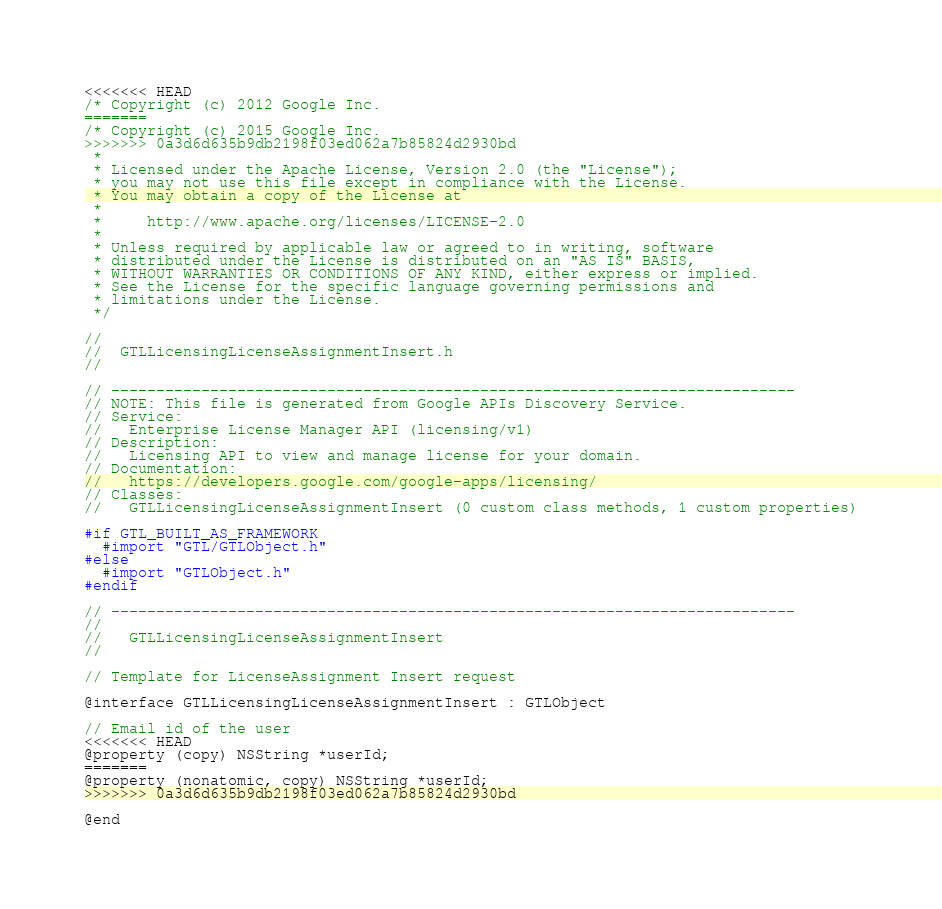<code> <loc_0><loc_0><loc_500><loc_500><_C_><<<<<<< HEAD
/* Copyright (c) 2012 Google Inc.
=======
/* Copyright (c) 2015 Google Inc.
>>>>>>> 0a3d6d635b9db2198f03ed062a7b85824d2930bd
 *
 * Licensed under the Apache License, Version 2.0 (the "License");
 * you may not use this file except in compliance with the License.
 * You may obtain a copy of the License at
 *
 *     http://www.apache.org/licenses/LICENSE-2.0
 *
 * Unless required by applicable law or agreed to in writing, software
 * distributed under the License is distributed on an "AS IS" BASIS,
 * WITHOUT WARRANTIES OR CONDITIONS OF ANY KIND, either express or implied.
 * See the License for the specific language governing permissions and
 * limitations under the License.
 */

//
//  GTLLicensingLicenseAssignmentInsert.h
//

// ----------------------------------------------------------------------------
// NOTE: This file is generated from Google APIs Discovery Service.
// Service:
//   Enterprise License Manager API (licensing/v1)
// Description:
//   Licensing API to view and manage license for your domain.
// Documentation:
//   https://developers.google.com/google-apps/licensing/
// Classes:
//   GTLLicensingLicenseAssignmentInsert (0 custom class methods, 1 custom properties)

#if GTL_BUILT_AS_FRAMEWORK
  #import "GTL/GTLObject.h"
#else
  #import "GTLObject.h"
#endif

// ----------------------------------------------------------------------------
//
//   GTLLicensingLicenseAssignmentInsert
//

// Template for LicenseAssignment Insert request

@interface GTLLicensingLicenseAssignmentInsert : GTLObject

// Email id of the user
<<<<<<< HEAD
@property (copy) NSString *userId;
=======
@property (nonatomic, copy) NSString *userId;
>>>>>>> 0a3d6d635b9db2198f03ed062a7b85824d2930bd

@end
</code> 